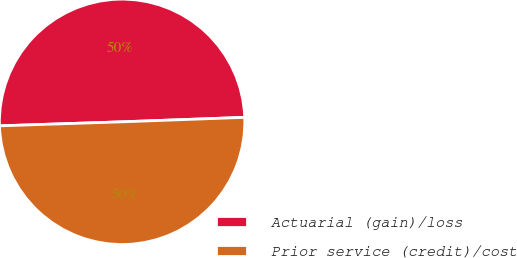Convert chart. <chart><loc_0><loc_0><loc_500><loc_500><pie_chart><fcel>Actuarial (gain)/loss<fcel>Prior service (credit)/cost<nl><fcel>49.94%<fcel>50.06%<nl></chart> 